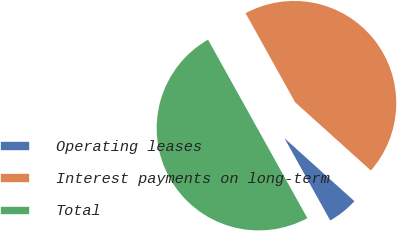<chart> <loc_0><loc_0><loc_500><loc_500><pie_chart><fcel>Operating leases<fcel>Interest payments on long-term<fcel>Total<nl><fcel>5.25%<fcel>44.75%<fcel>50.0%<nl></chart> 